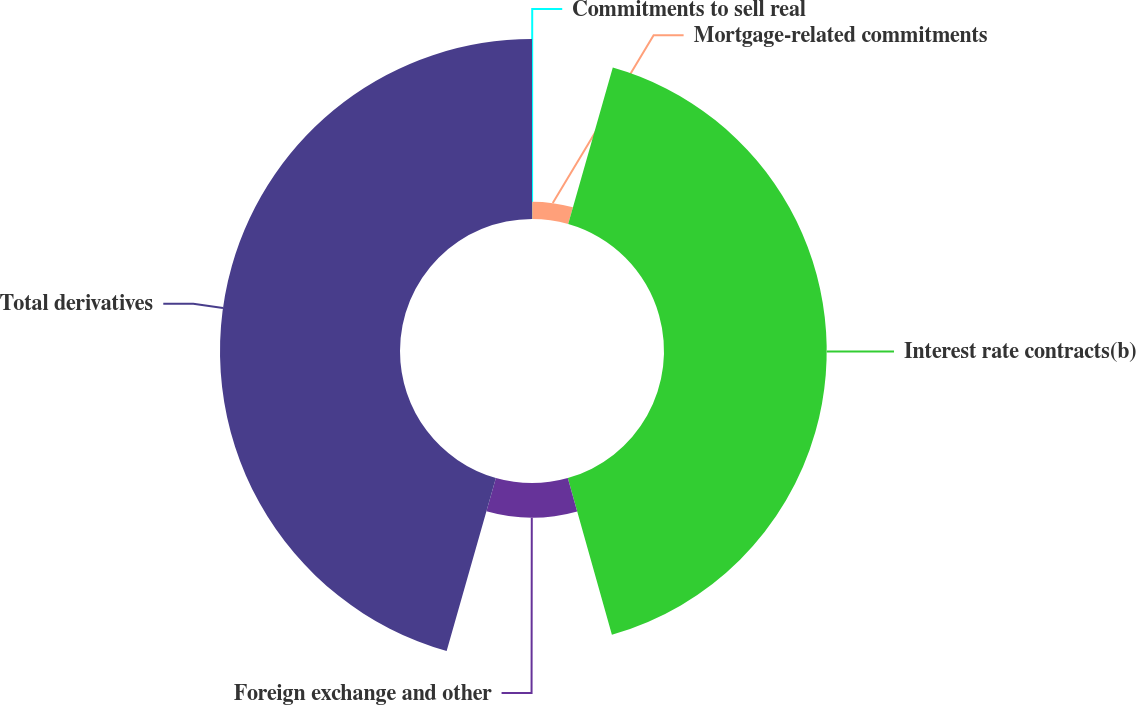Convert chart to OTSL. <chart><loc_0><loc_0><loc_500><loc_500><pie_chart><fcel>Commitments to sell real<fcel>Mortgage-related commitments<fcel>Interest rate contracts(b)<fcel>Foreign exchange and other<fcel>Total derivatives<nl><fcel>0.02%<fcel>4.4%<fcel>41.21%<fcel>8.78%<fcel>45.59%<nl></chart> 